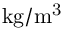Convert formula to latex. <formula><loc_0><loc_0><loc_500><loc_500>k g / m ^ { 3 }</formula> 